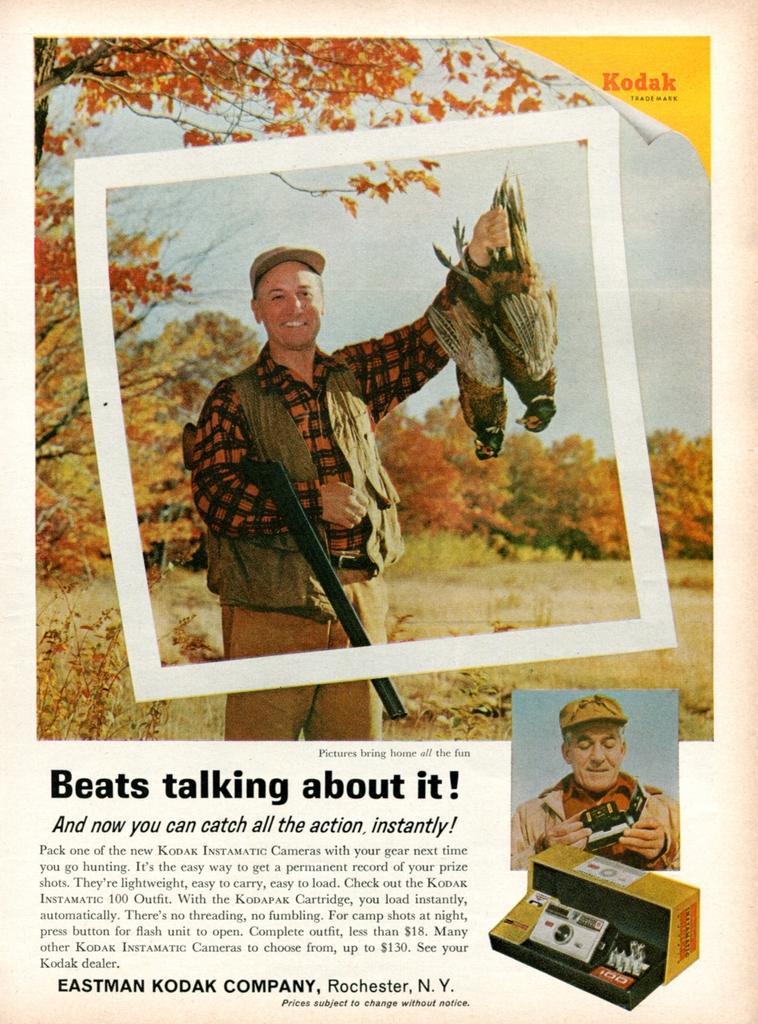Please provide a concise description of this image. This is a poster having three images and texts. In these three images, we can see there are persons, birds, trees, plants, sky and an object. 